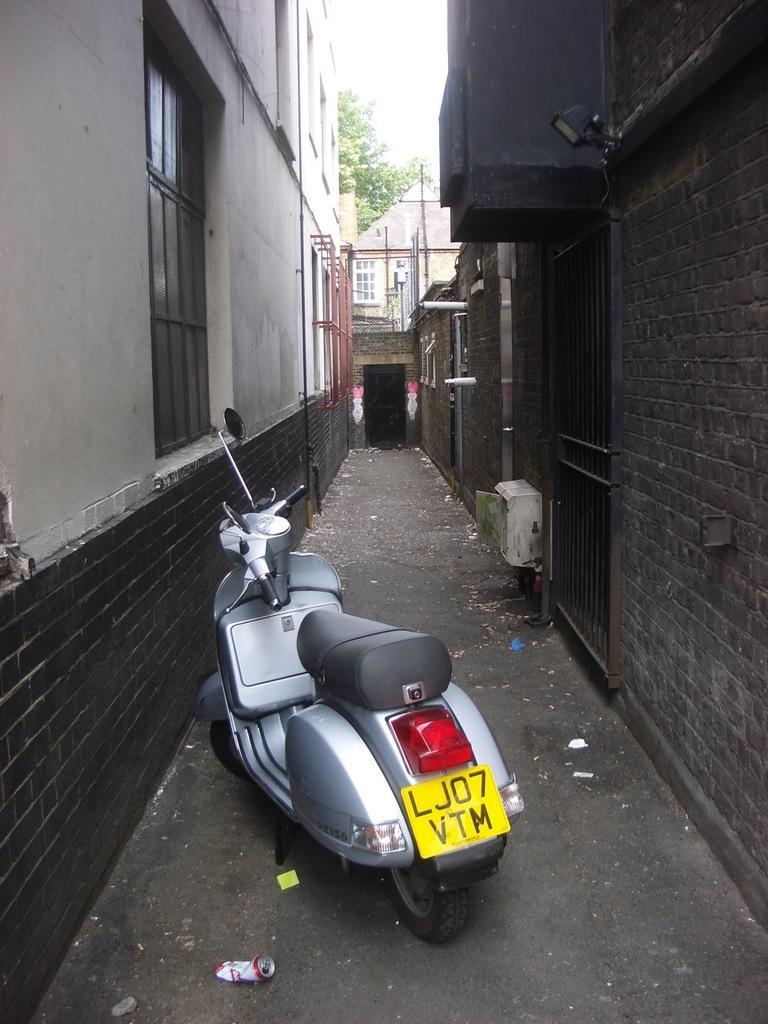Describe this image in one or two sentences. As we can see in the image there is a motorcycle, buildings, window, tree and sky. 